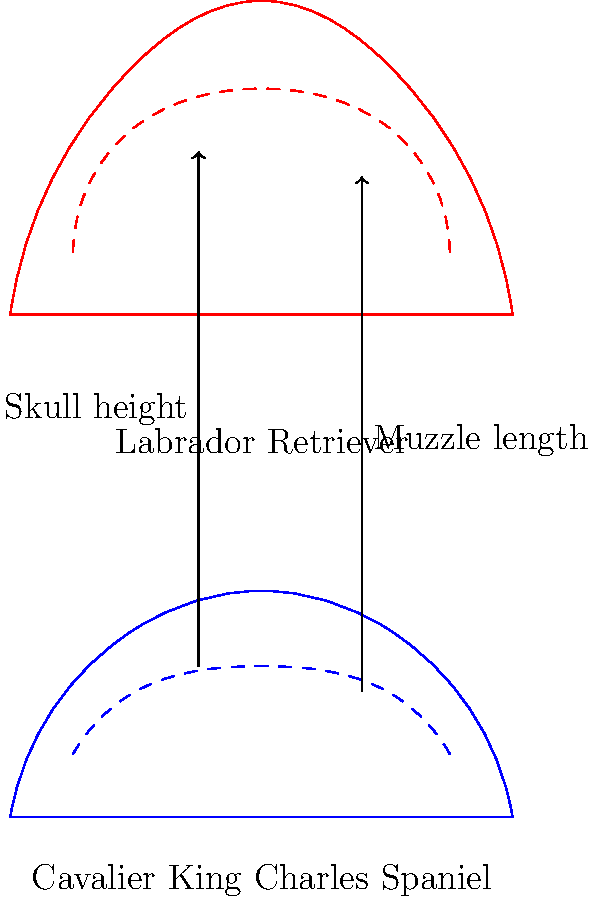Comparing the skeletal structure of a Cavalier King Charles Spaniel to a Labrador Retriever, which characteristic is most distinctive in the Cavalier's skull, and how does it relate to the breed's common health concerns? 1. Observe the diagram: The blue outline represents the Cavalier King Charles Spaniel, while the red outline represents the Labrador Retriever.

2. Compare skull shapes: The Cavalier's skull (blue dashed line) is noticeably smaller and more rounded compared to the Labrador's skull (red dashed line).

3. Identify key differences:
   a. Skull height: The Cavalier's skull is significantly shorter vertically.
   b. Muzzle length: The Cavalier has a much shorter muzzle compared to the Labrador.

4. Most distinctive characteristic: The most prominent feature is the Cavalier's extremely short muzzle and rounded skull, a condition known as brachycephaly.

5. Health concerns: Brachycephaly in Cavaliers is associated with:
   a. Chiari-like malformation (CM): The skull is too small for the brain, potentially compressing the cerebellum and brainstem.
   b. Syringomyelia: A condition where fluid-filled cavities develop in the spinal cord, often resulting from CM.

6. Relation to health: The shortened skull and muzzle can lead to:
   a. Breathing difficulties due to narrowed airways
   b. Dental problems from overcrowded teeth
   c. Eye issues, as the eyes are more prominent and less protected

7. Conclusion: The Cavalier's distinctive brachycephalic skull structure, while giving the breed its characteristic appearance, is directly linked to several potential health issues.
Answer: Brachycephaly (shortened skull and muzzle), linked to Chiari-like malformation and syringomyelia. 